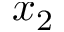Convert formula to latex. <formula><loc_0><loc_0><loc_500><loc_500>x _ { 2 }</formula> 